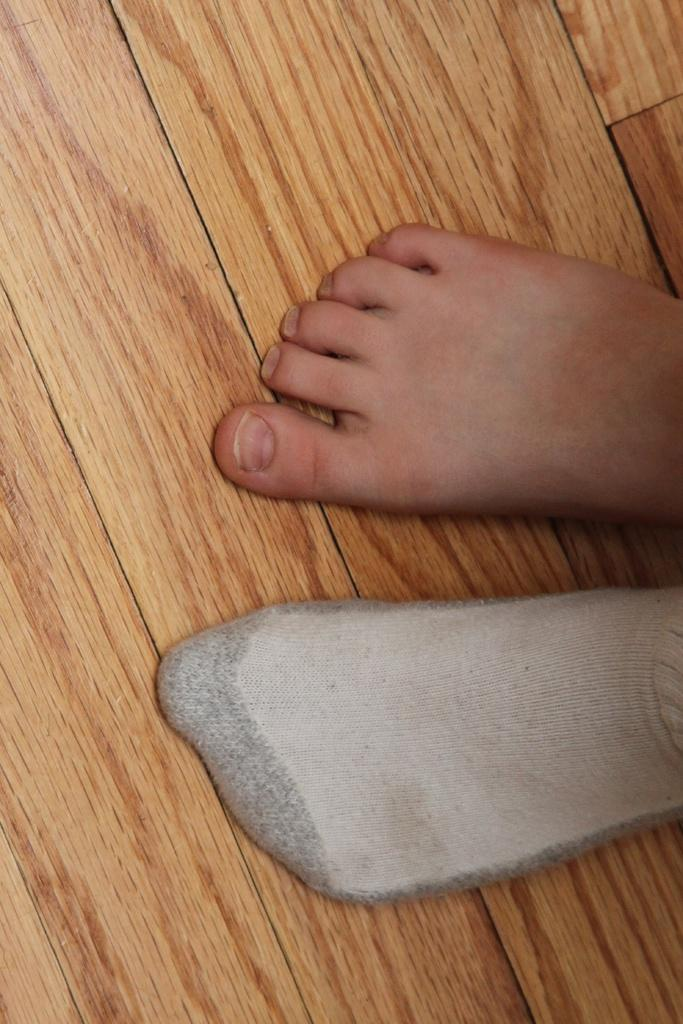What type of flooring is present in the image? There is a wooden floor in the image. What can be seen on the wooden floor? There are legs visible on the wooden floor. What type of chain is being used to control the reward in the image? There is no chain, control, or reward present in the image; it only features a wooden floor and legs. 